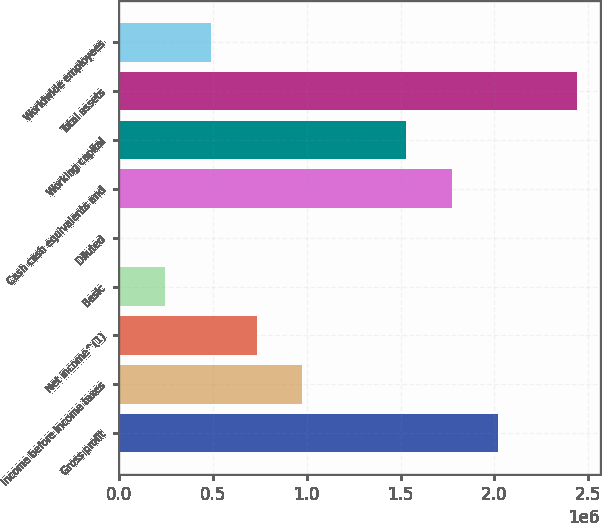Convert chart. <chart><loc_0><loc_0><loc_500><loc_500><bar_chart><fcel>Gross profit<fcel>Income before income taxes<fcel>Net income^(1)<fcel>Basic<fcel>Diluted<fcel>Cash cash equivalents and<fcel>Working capital<fcel>Total assets<fcel>Worldwide employees<nl><fcel>2.01698e+06<fcel>976127<fcel>732095<fcel>244033<fcel>1.19<fcel>1.77295e+06<fcel>1.52892e+06<fcel>2.44032e+06<fcel>488064<nl></chart> 